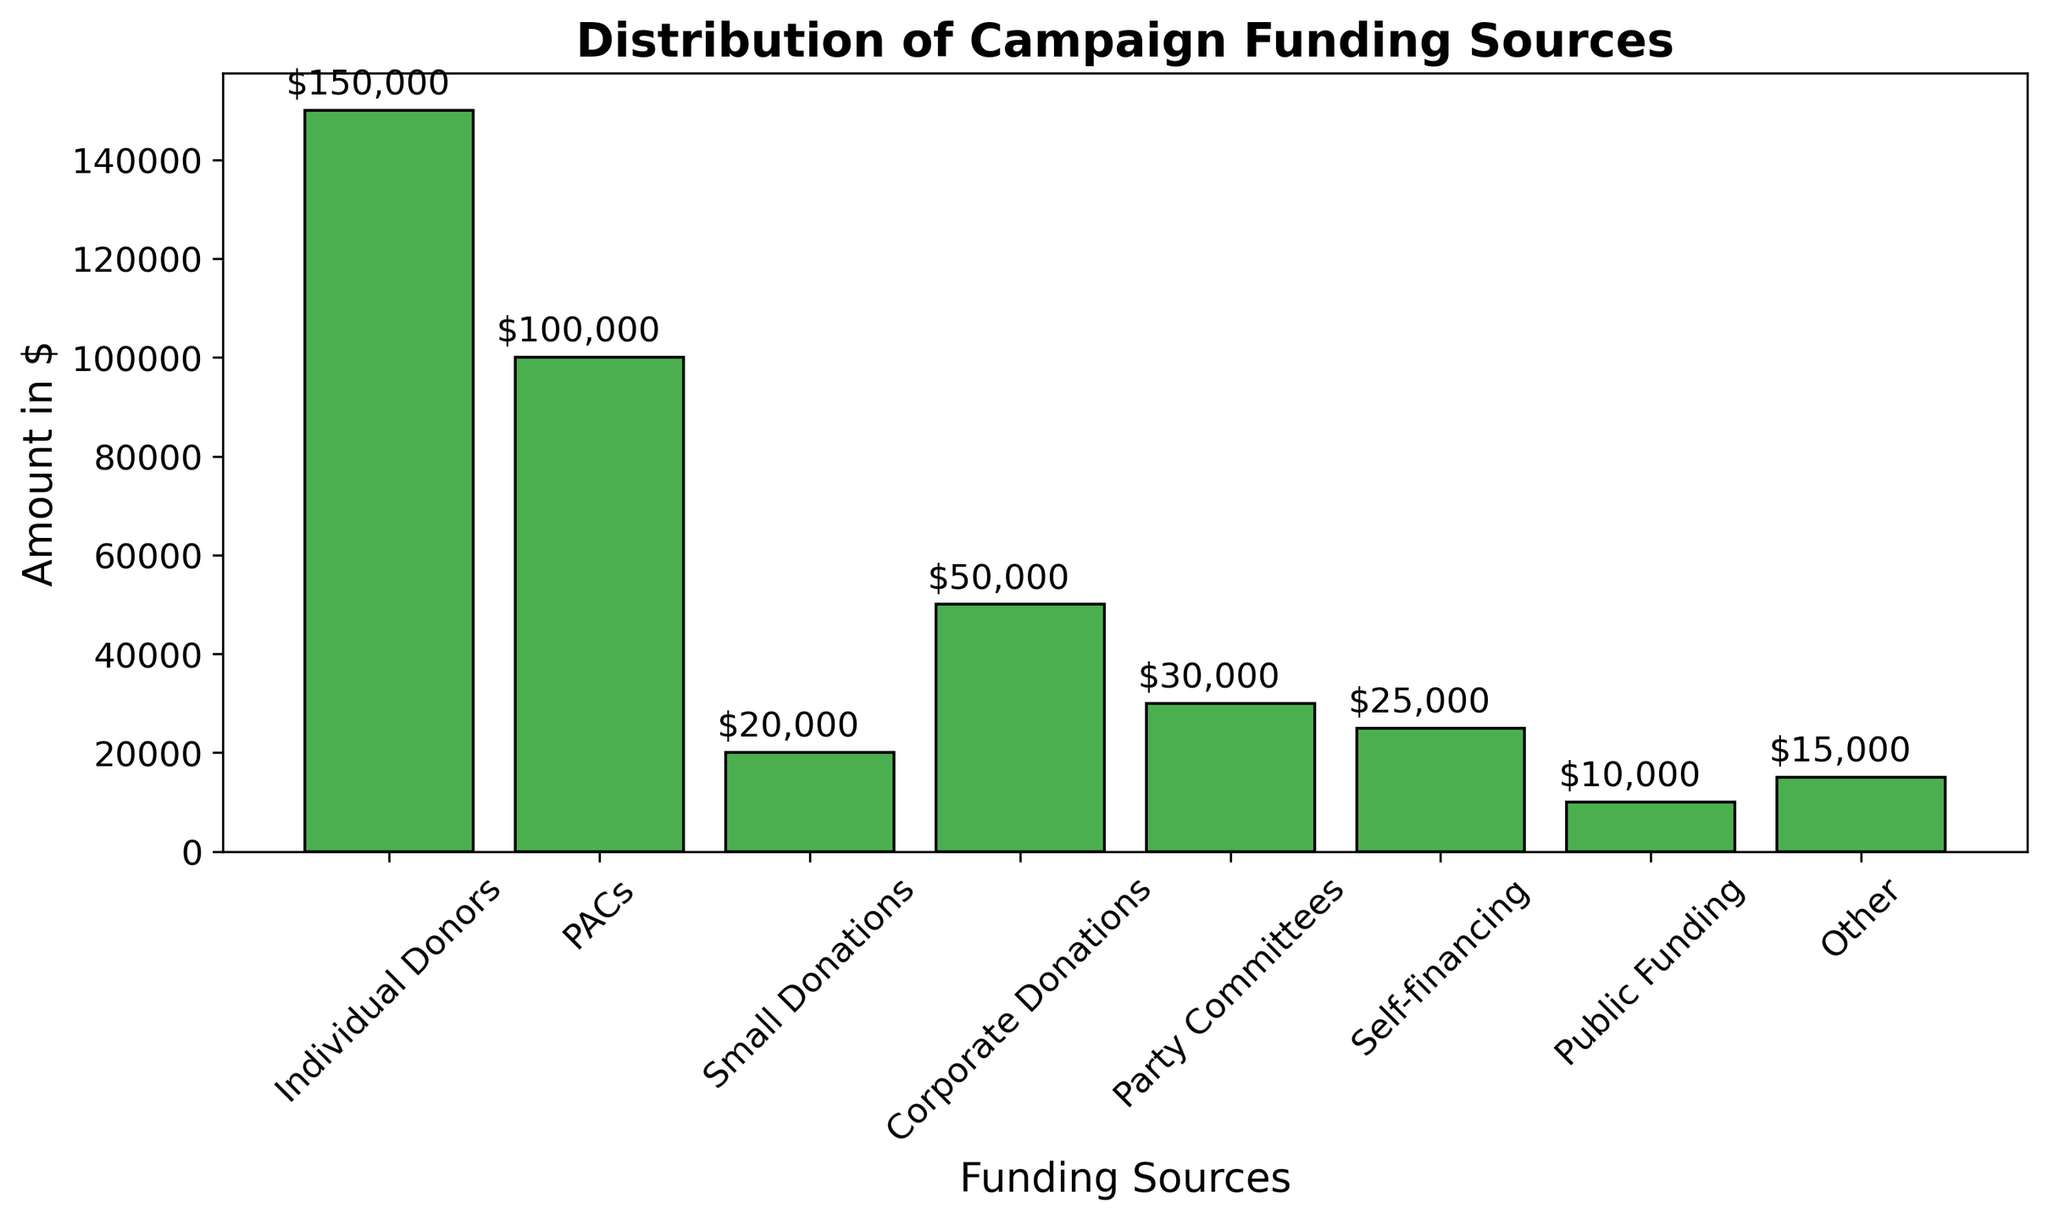What is the total amount received from individual donors and PACs? To find the total amount received from individual donors and PACs, add the amount from individual donors ($150,000) and the amount from PACs ($100,000). The sum is $150,000 + $100,000 = $250,000.
Answer: $250,000 Which funding source contributed the smallest amount? By visually comparing the heights of the bars, the bar representing public funding is the shortest. Public funding contributed the smallest amount, which is $10,000.
Answer: Public Funding How much more funding did individual donors provide compared to corporate donations? To find the difference between the funding from individual donors and corporate donations, subtract the amount from corporate donations ($50,000) from the amount from individual donors ($150,000). The difference is $150,000 - $50,000 = $100,000.
Answer: $100,000 What is the average amount contributed by PACs, party committees, and self-financing? To find the average, first add the amounts from PACs ($100,000), party committees ($30,000), and self-financing ($25,000). The sum is $100,000 + $30,000 + $25,000 = $155,000. Then, divide the total by the number of sources (3). The average is $155,000/3 ≈ $51,667.
Answer: $51,667 Which two funding sources combined have the same total amount as individual donors? First, observe the bars and check combinations. PACs and corporate donations amount to $100,000 + $50,000 = $150,000, which is the same as individual donors ($150,000).
Answer: PACs and Corporate Donations Is the amount from small donations greater than the amount from party committees? By comparing the bar heights, the small donations bar ($20,000) is taller than the party committees bar ($30,000). Clearly, $20,000 is less than $30,000.
Answer: No How much more funding is there from small donations compared to self-financing? To find the difference, subtract the amount from self-financing ($25,000) from the amount from small donations ($20,000). Since $25,000 is greater than $20,000, subtract $20,000 from $25,000 which gives $5,000. Self-financing provides more than small donations.
Answer: -$5,000 (Self-financing gives more) What proportion of the total funding does individual donors contribute? First, sum up all the contributions: $150,000 (Individual Donors) + $100,000 (PACs) + $20,000 (Small Donations) + $50,000 (Corporate Donations) + $30,000 (Party Committees) + $25,000 (Self-financing) + $10,000 (Public Funding) + $15,000 (Other) = $400,000. Then, divide the contribution from individual donors by the total and convert to percentage: ($150,000 / $400,000) * 100 = 37.5%.
Answer: 37.5% How many sources contribute less than 10% of the total funding? First, calculate 10% of the total funding ($400,000) which is $40,000. Then, count the sources with amounts less than $40,000: Party Committees ($30,000), Self-financing ($25,000), Public Funding ($10,000), Other ($15,000). There are 4 such sources.
Answer: 4 sources 